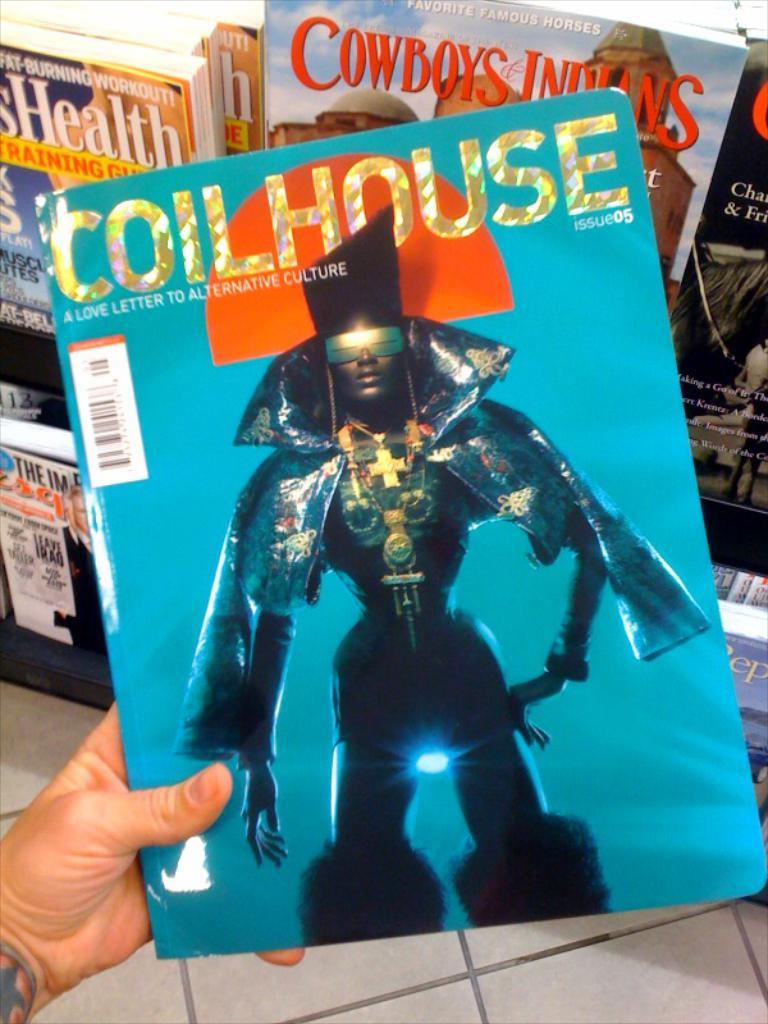<image>
Summarize the visual content of the image. An interesting magazine stating it is a love letter to alternative culture. 